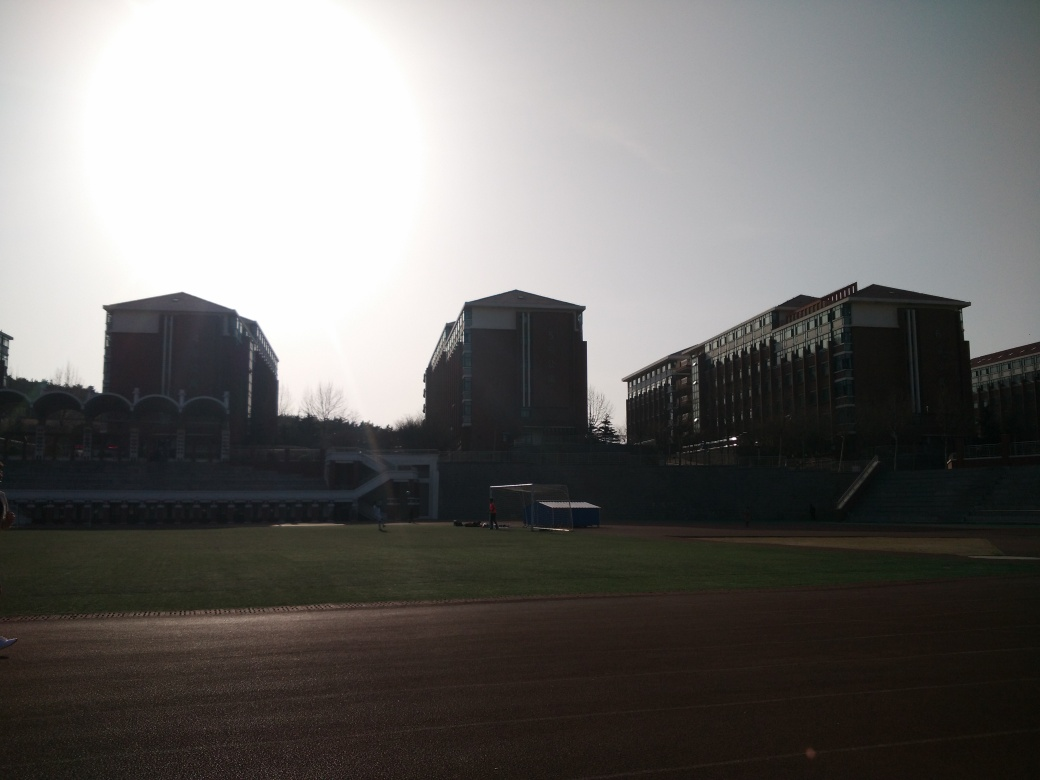What events might take place in this location? The presence of a track and field suggests that athletic events, such as track meets, soccer games, and other sports competitions, are likely to be held here. The seating area also indicates that this venue can accommodate an audience, making it suitable for ceremonies or outdoor performances. 